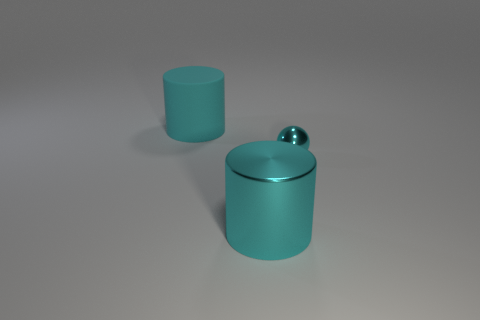What is the color of the big thing behind the shiny thing that is on the left side of the metallic thing that is behind the cyan metal cylinder?
Your answer should be compact. Cyan. Is the number of tiny things that are to the right of the cyan metallic cylinder greater than the number of cyan shiny balls on the left side of the sphere?
Ensure brevity in your answer.  Yes. What number of other things are the same size as the cyan matte cylinder?
Ensure brevity in your answer.  1. There is another cylinder that is the same color as the big matte cylinder; what size is it?
Make the answer very short. Large. The cyan object that is on the right side of the big object that is in front of the large rubber cylinder is made of what material?
Your answer should be compact. Metal. Are there any cyan metallic balls in front of the ball?
Your answer should be compact. No. Are there more matte objects that are behind the large shiny thing than small purple rubber things?
Your answer should be very brief. Yes. Is there a metallic cylinder of the same color as the small shiny sphere?
Offer a very short reply. Yes. What color is the other object that is the same size as the matte object?
Offer a terse response. Cyan. There is a cyan cylinder in front of the matte cylinder; are there any large cyan metallic cylinders that are in front of it?
Provide a short and direct response. No. 